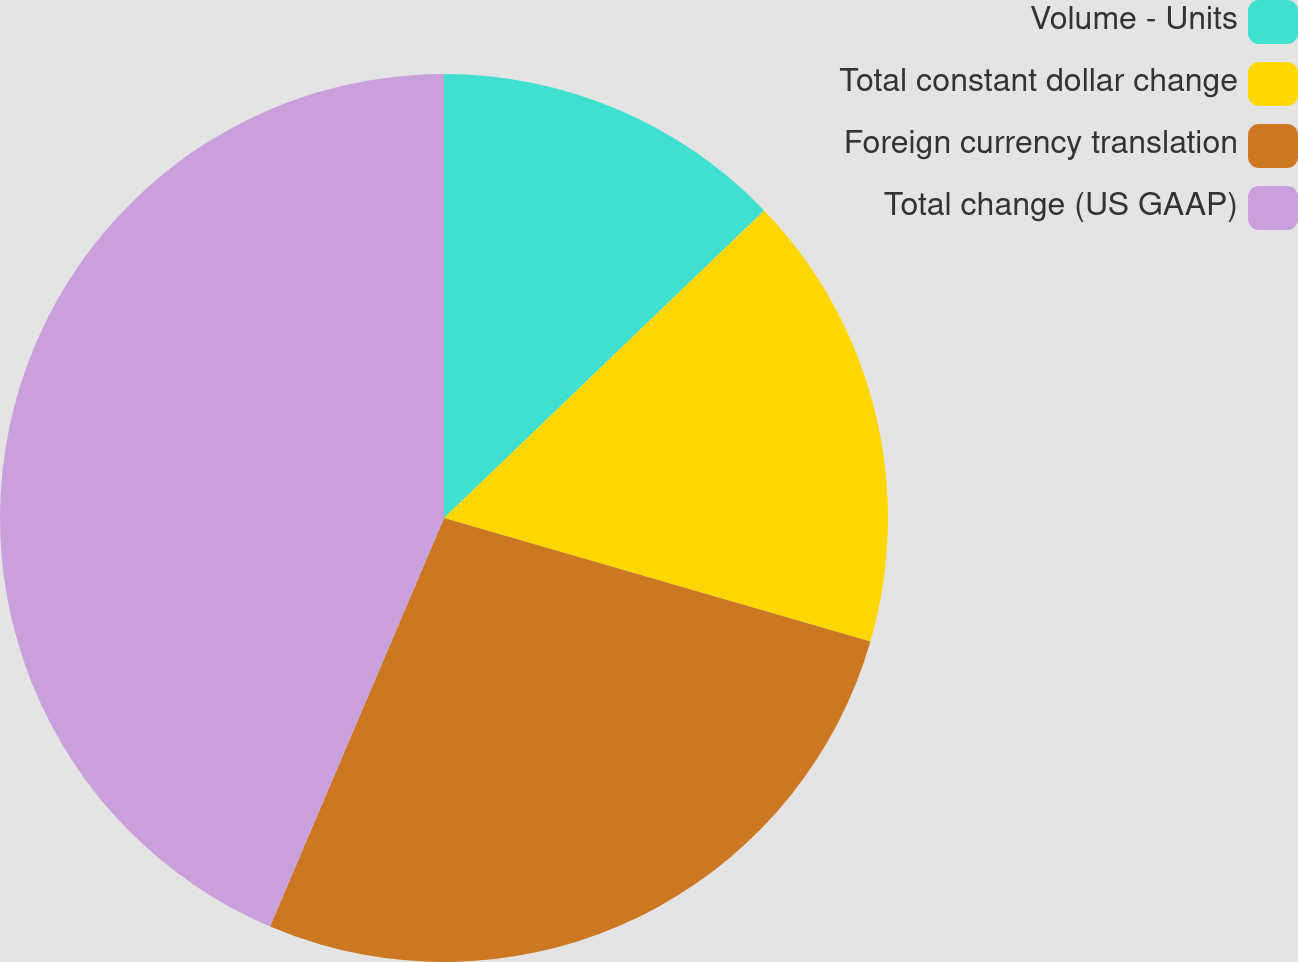Convert chart to OTSL. <chart><loc_0><loc_0><loc_500><loc_500><pie_chart><fcel>Volume - Units<fcel>Total constant dollar change<fcel>Foreign currency translation<fcel>Total change (US GAAP)<nl><fcel>12.82%<fcel>16.67%<fcel>26.92%<fcel>43.59%<nl></chart> 